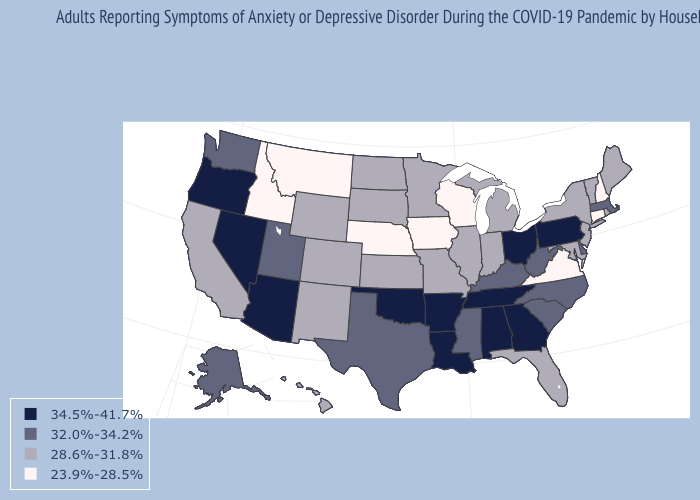Does Oregon have the lowest value in the USA?
Keep it brief. No. Does Colorado have a higher value than Iowa?
Give a very brief answer. Yes. What is the value of New Jersey?
Concise answer only. 28.6%-31.8%. Does Missouri have the lowest value in the USA?
Keep it brief. No. What is the value of Iowa?
Quick response, please. 23.9%-28.5%. What is the value of Hawaii?
Quick response, please. 28.6%-31.8%. Does the first symbol in the legend represent the smallest category?
Short answer required. No. Name the states that have a value in the range 28.6%-31.8%?
Answer briefly. California, Colorado, Florida, Hawaii, Illinois, Indiana, Kansas, Maine, Maryland, Michigan, Minnesota, Missouri, New Jersey, New Mexico, New York, North Dakota, Rhode Island, South Dakota, Vermont, Wyoming. Name the states that have a value in the range 32.0%-34.2%?
Give a very brief answer. Alaska, Delaware, Kentucky, Massachusetts, Mississippi, North Carolina, South Carolina, Texas, Utah, Washington, West Virginia. What is the lowest value in the USA?
Answer briefly. 23.9%-28.5%. What is the value of Michigan?
Short answer required. 28.6%-31.8%. Name the states that have a value in the range 32.0%-34.2%?
Short answer required. Alaska, Delaware, Kentucky, Massachusetts, Mississippi, North Carolina, South Carolina, Texas, Utah, Washington, West Virginia. Does North Carolina have a lower value than Kansas?
Be succinct. No. Does Idaho have the lowest value in the USA?
Answer briefly. Yes. Does Maryland have the lowest value in the USA?
Write a very short answer. No. 